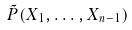Convert formula to latex. <formula><loc_0><loc_0><loc_500><loc_500>\tilde { P } ( X _ { 1 } , \dots , X _ { n - 1 } )</formula> 